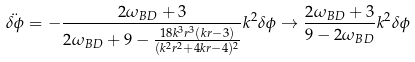Convert formula to latex. <formula><loc_0><loc_0><loc_500><loc_500>\ddot { \delta \phi } = - \frac { 2 \omega _ { B D } + 3 } { 2 \omega _ { B D } + 9 - \frac { 1 8 k ^ { 3 } r ^ { 3 } ( k r - 3 ) } { ( k ^ { 2 } r ^ { 2 } + 4 k r - 4 ) ^ { 2 } } } k ^ { 2 } \delta \phi \to \frac { 2 \omega _ { B D } + 3 } { 9 - 2 \omega _ { B D } } k ^ { 2 } \delta \phi</formula> 